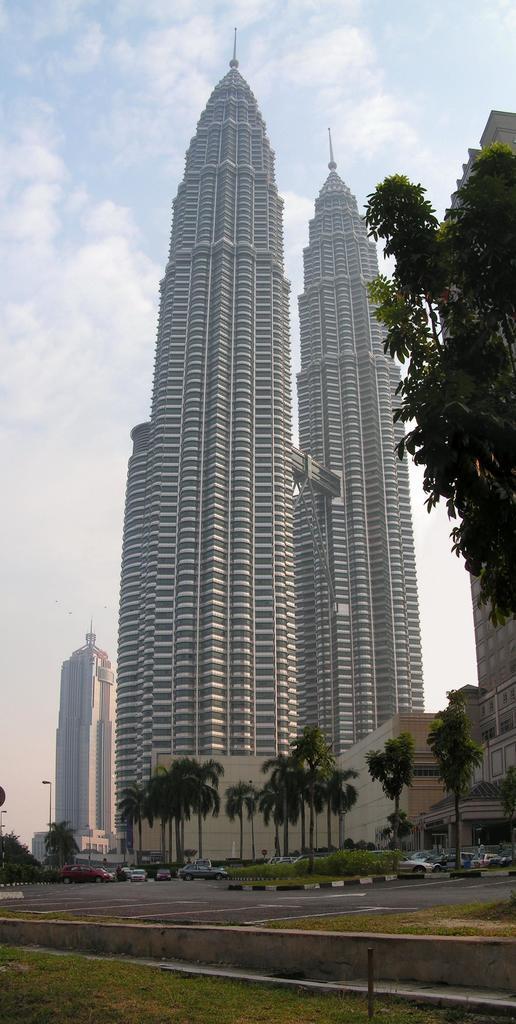Could you give a brief overview of what you see in this image? In this image I can see the road, background I can see few vehicles, trees in green color, buildings in white and brown and the sky is in white and blue color. 